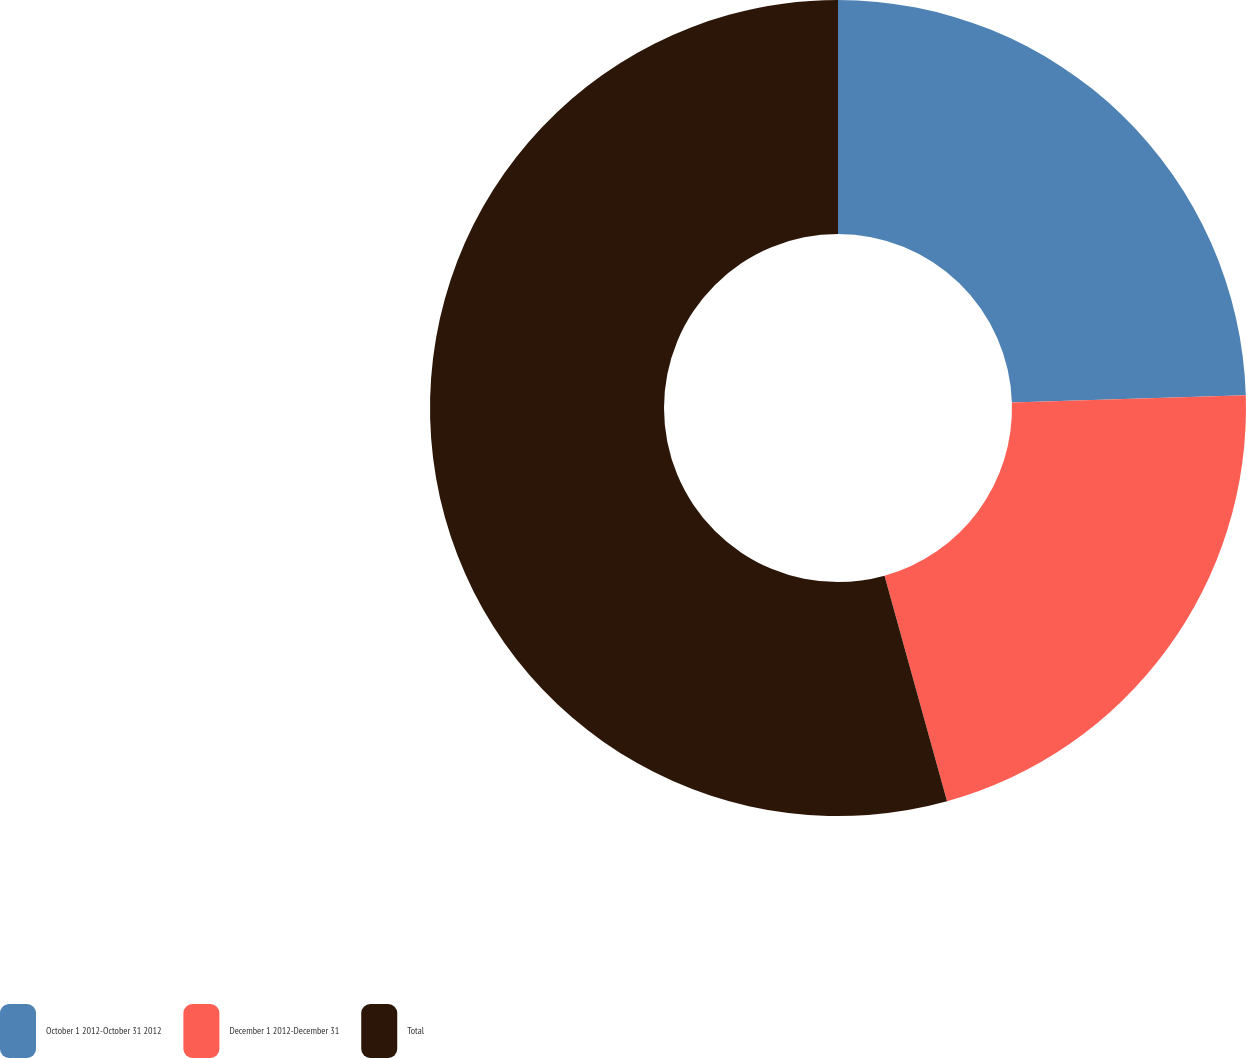Convert chart. <chart><loc_0><loc_0><loc_500><loc_500><pie_chart><fcel>October 1 2012-October 31 2012<fcel>December 1 2012-December 31<fcel>Total<nl><fcel>24.5%<fcel>21.19%<fcel>54.3%<nl></chart> 